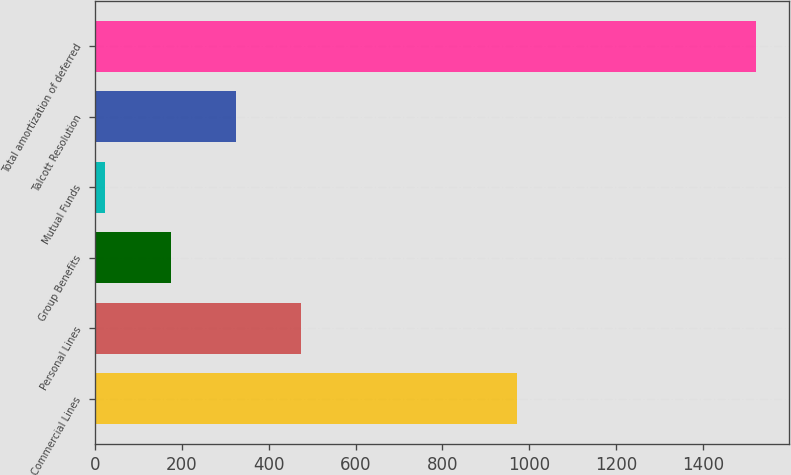Convert chart to OTSL. <chart><loc_0><loc_0><loc_500><loc_500><bar_chart><fcel>Commercial Lines<fcel>Personal Lines<fcel>Group Benefits<fcel>Mutual Funds<fcel>Talcott Resolution<fcel>Total amortization of deferred<nl><fcel>973<fcel>473.7<fcel>173.9<fcel>24<fcel>323.8<fcel>1523<nl></chart> 